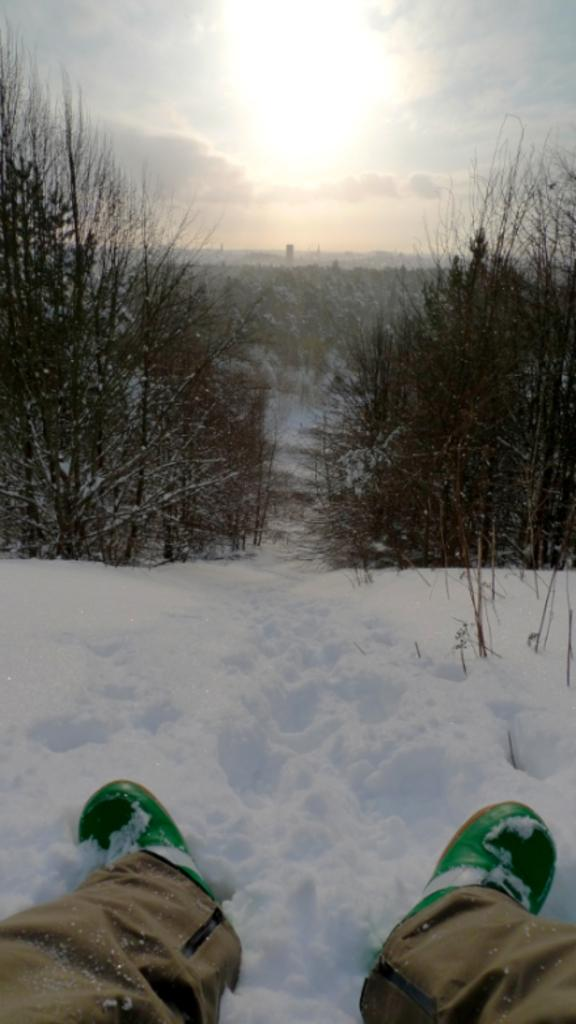What part of a person can be seen in the image? There are legs of a person visible in the image. Where are the legs located? The legs are on the snow. What type of vegetation is present in the image? There are trees in the image. What is the ground made of in the image? The ground is covered in snow. What can be seen in the background of the image? The sky is visible in the background of the image. What type of beast can be seen roaming in the snow in the image? There is no beast present in the image; it only features the legs of a person on the snow. 